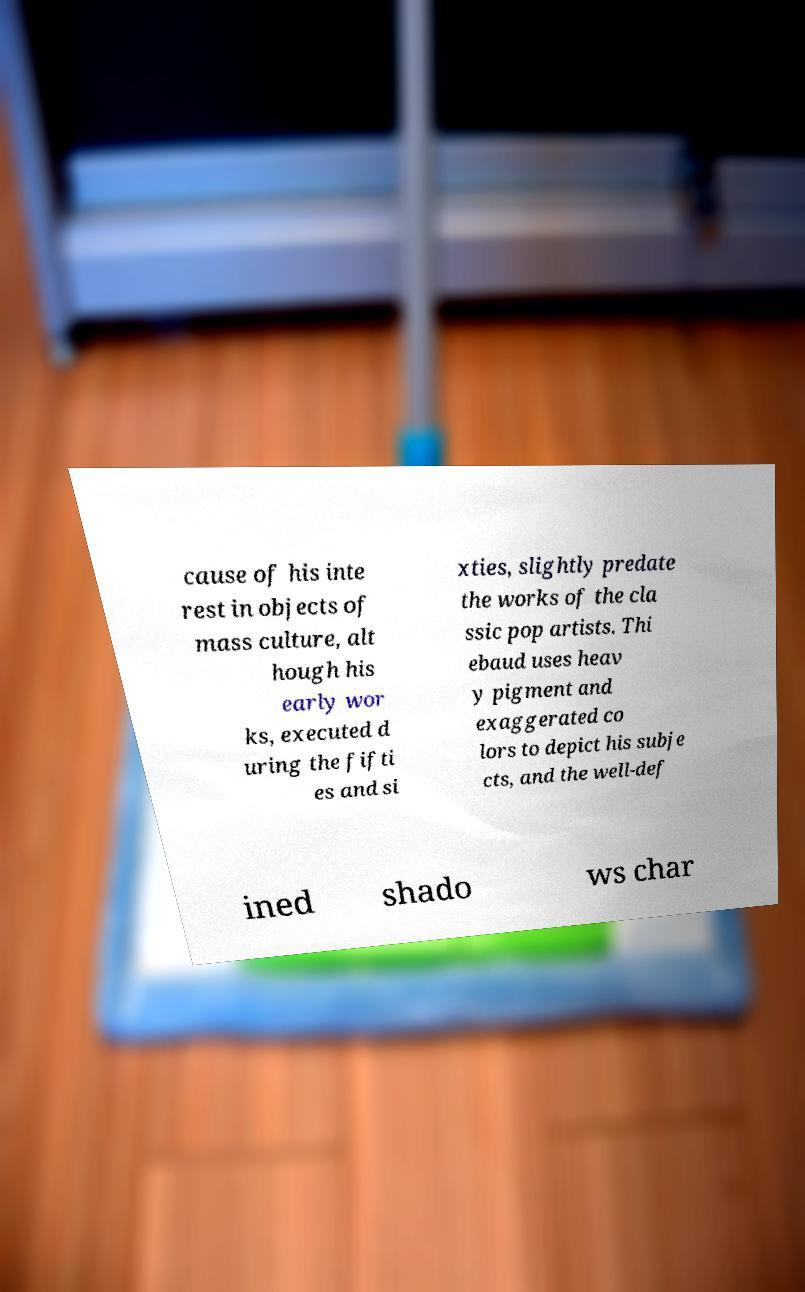Could you extract and type out the text from this image? cause of his inte rest in objects of mass culture, alt hough his early wor ks, executed d uring the fifti es and si xties, slightly predate the works of the cla ssic pop artists. Thi ebaud uses heav y pigment and exaggerated co lors to depict his subje cts, and the well-def ined shado ws char 